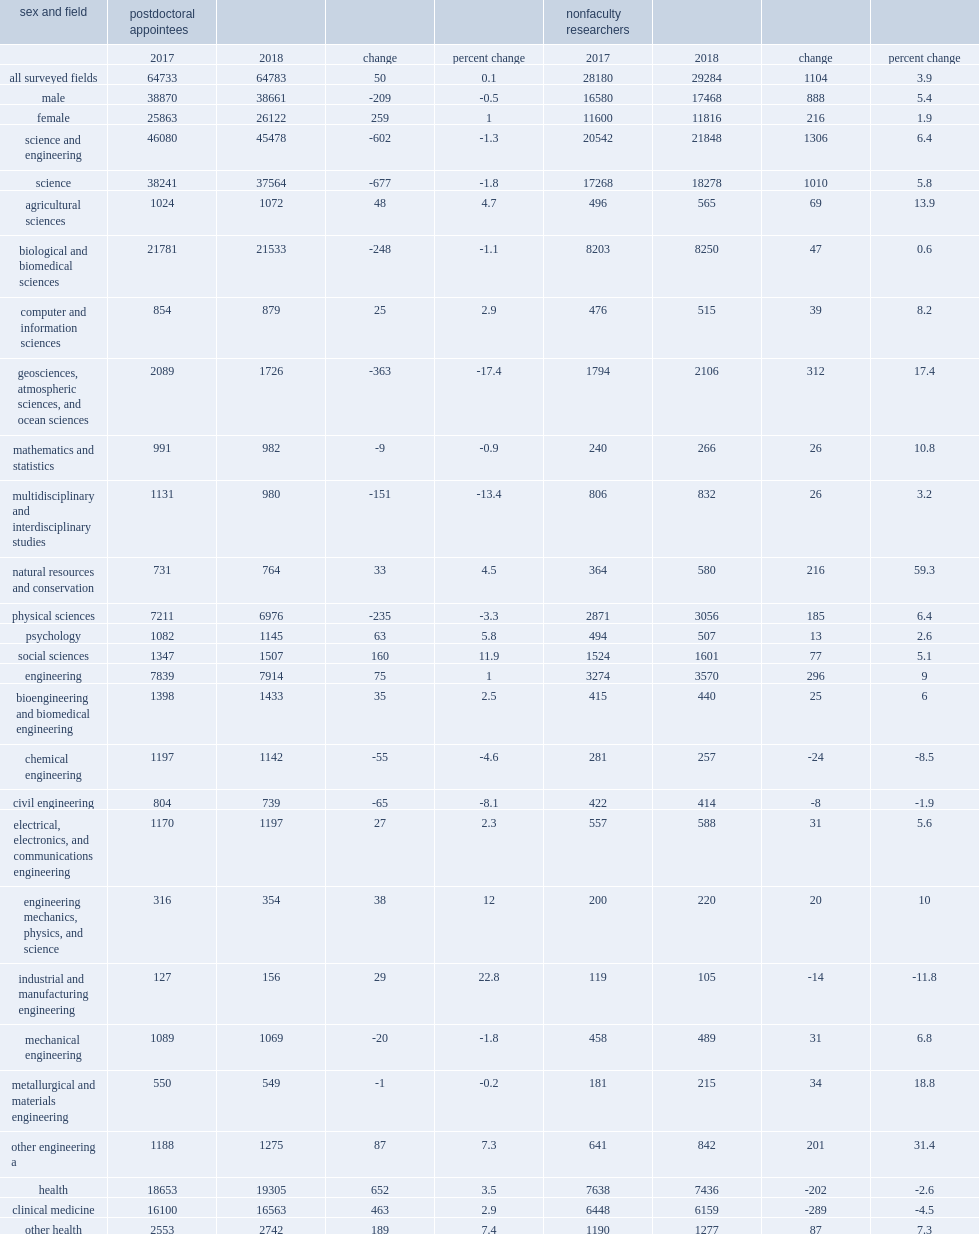What was the number of postdocs in seh fields of study in 2017? 64733.0. What was the number of postdocs in seh fields of study in 2018? 64783.0. How many students did geosciences, atmospheric sciences, and ocean sciences see the largest decrease in the number of postdocs? 363. How many students did clinical medicine which saw the largest increase in number of postdocs rise by? 463. Between 2017 and 2018, what was the decrease of nfrs in clinical medicine? 289. 